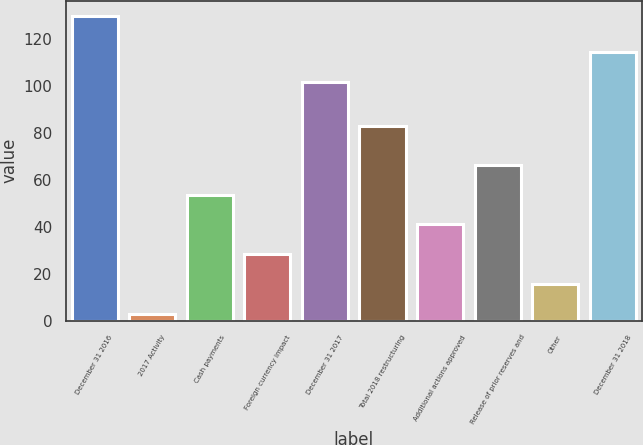<chart> <loc_0><loc_0><loc_500><loc_500><bar_chart><fcel>December 31 2016<fcel>2017 Activity<fcel>Cash payments<fcel>Foreign currency impact<fcel>December 31 2017<fcel>Total 2018 restructuring<fcel>Additional actions approved<fcel>Release of prior reserves and<fcel>Other<fcel>December 31 2018<nl><fcel>130<fcel>3<fcel>53.8<fcel>28.4<fcel>102<fcel>83<fcel>41.1<fcel>66.5<fcel>15.7<fcel>114.7<nl></chart> 